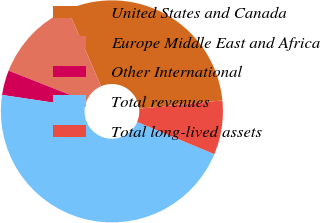Convert chart to OTSL. <chart><loc_0><loc_0><loc_500><loc_500><pie_chart><fcel>United States and Canada<fcel>Europe Middle East and Africa<fcel>Other International<fcel>Total revenues<fcel>Total long-lived assets<nl><fcel>29.92%<fcel>12.52%<fcel>3.62%<fcel>46.07%<fcel>7.87%<nl></chart> 